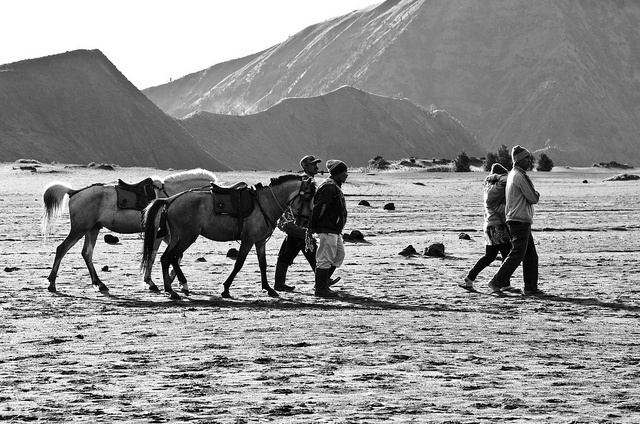Describe the objects in this image and their specific colors. I can see horse in white, black, gray, darkgray, and lightgray tones, horse in white, black, gray, darkgray, and lightgray tones, people in white, black, gray, darkgray, and lightgray tones, people in white, black, gray, darkgray, and lightgray tones, and people in white, black, gray, lightgray, and darkgray tones in this image. 